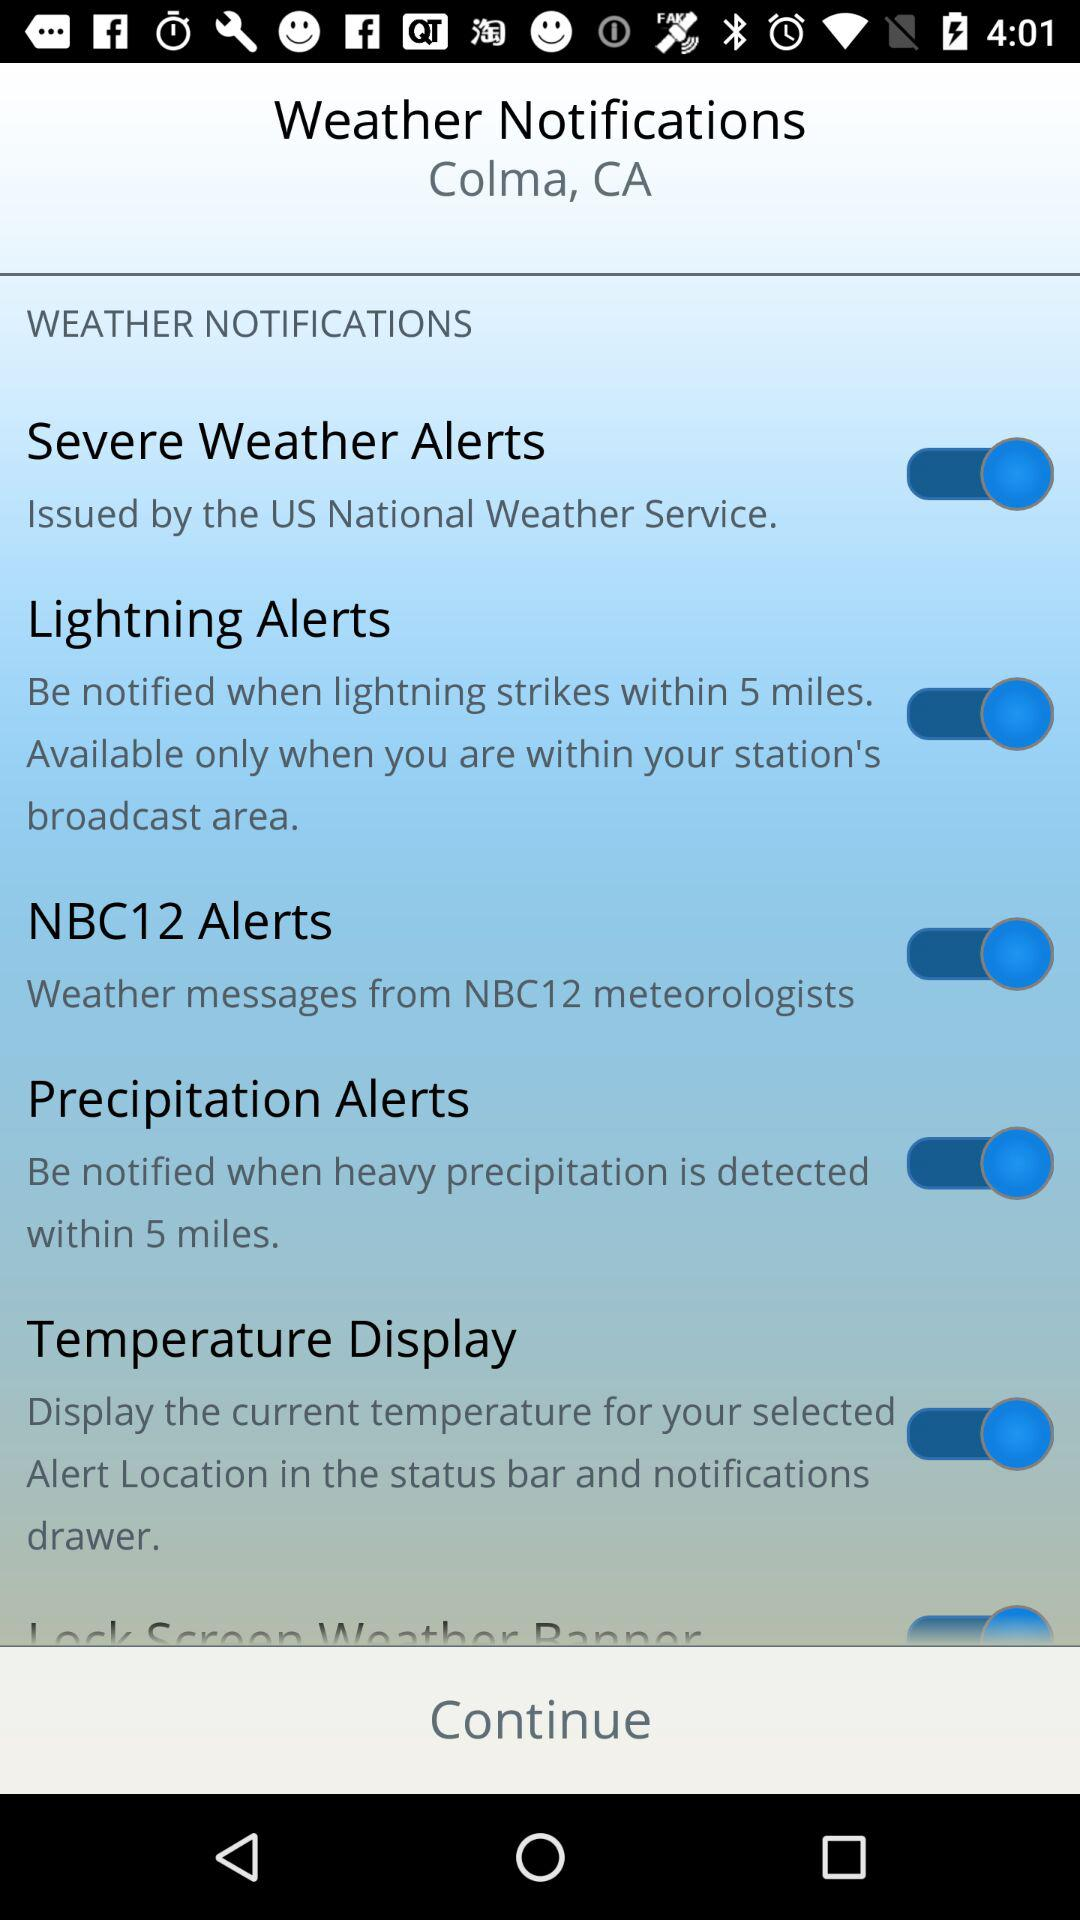What is the status of "Lightning Alerts"? The status is "on". 